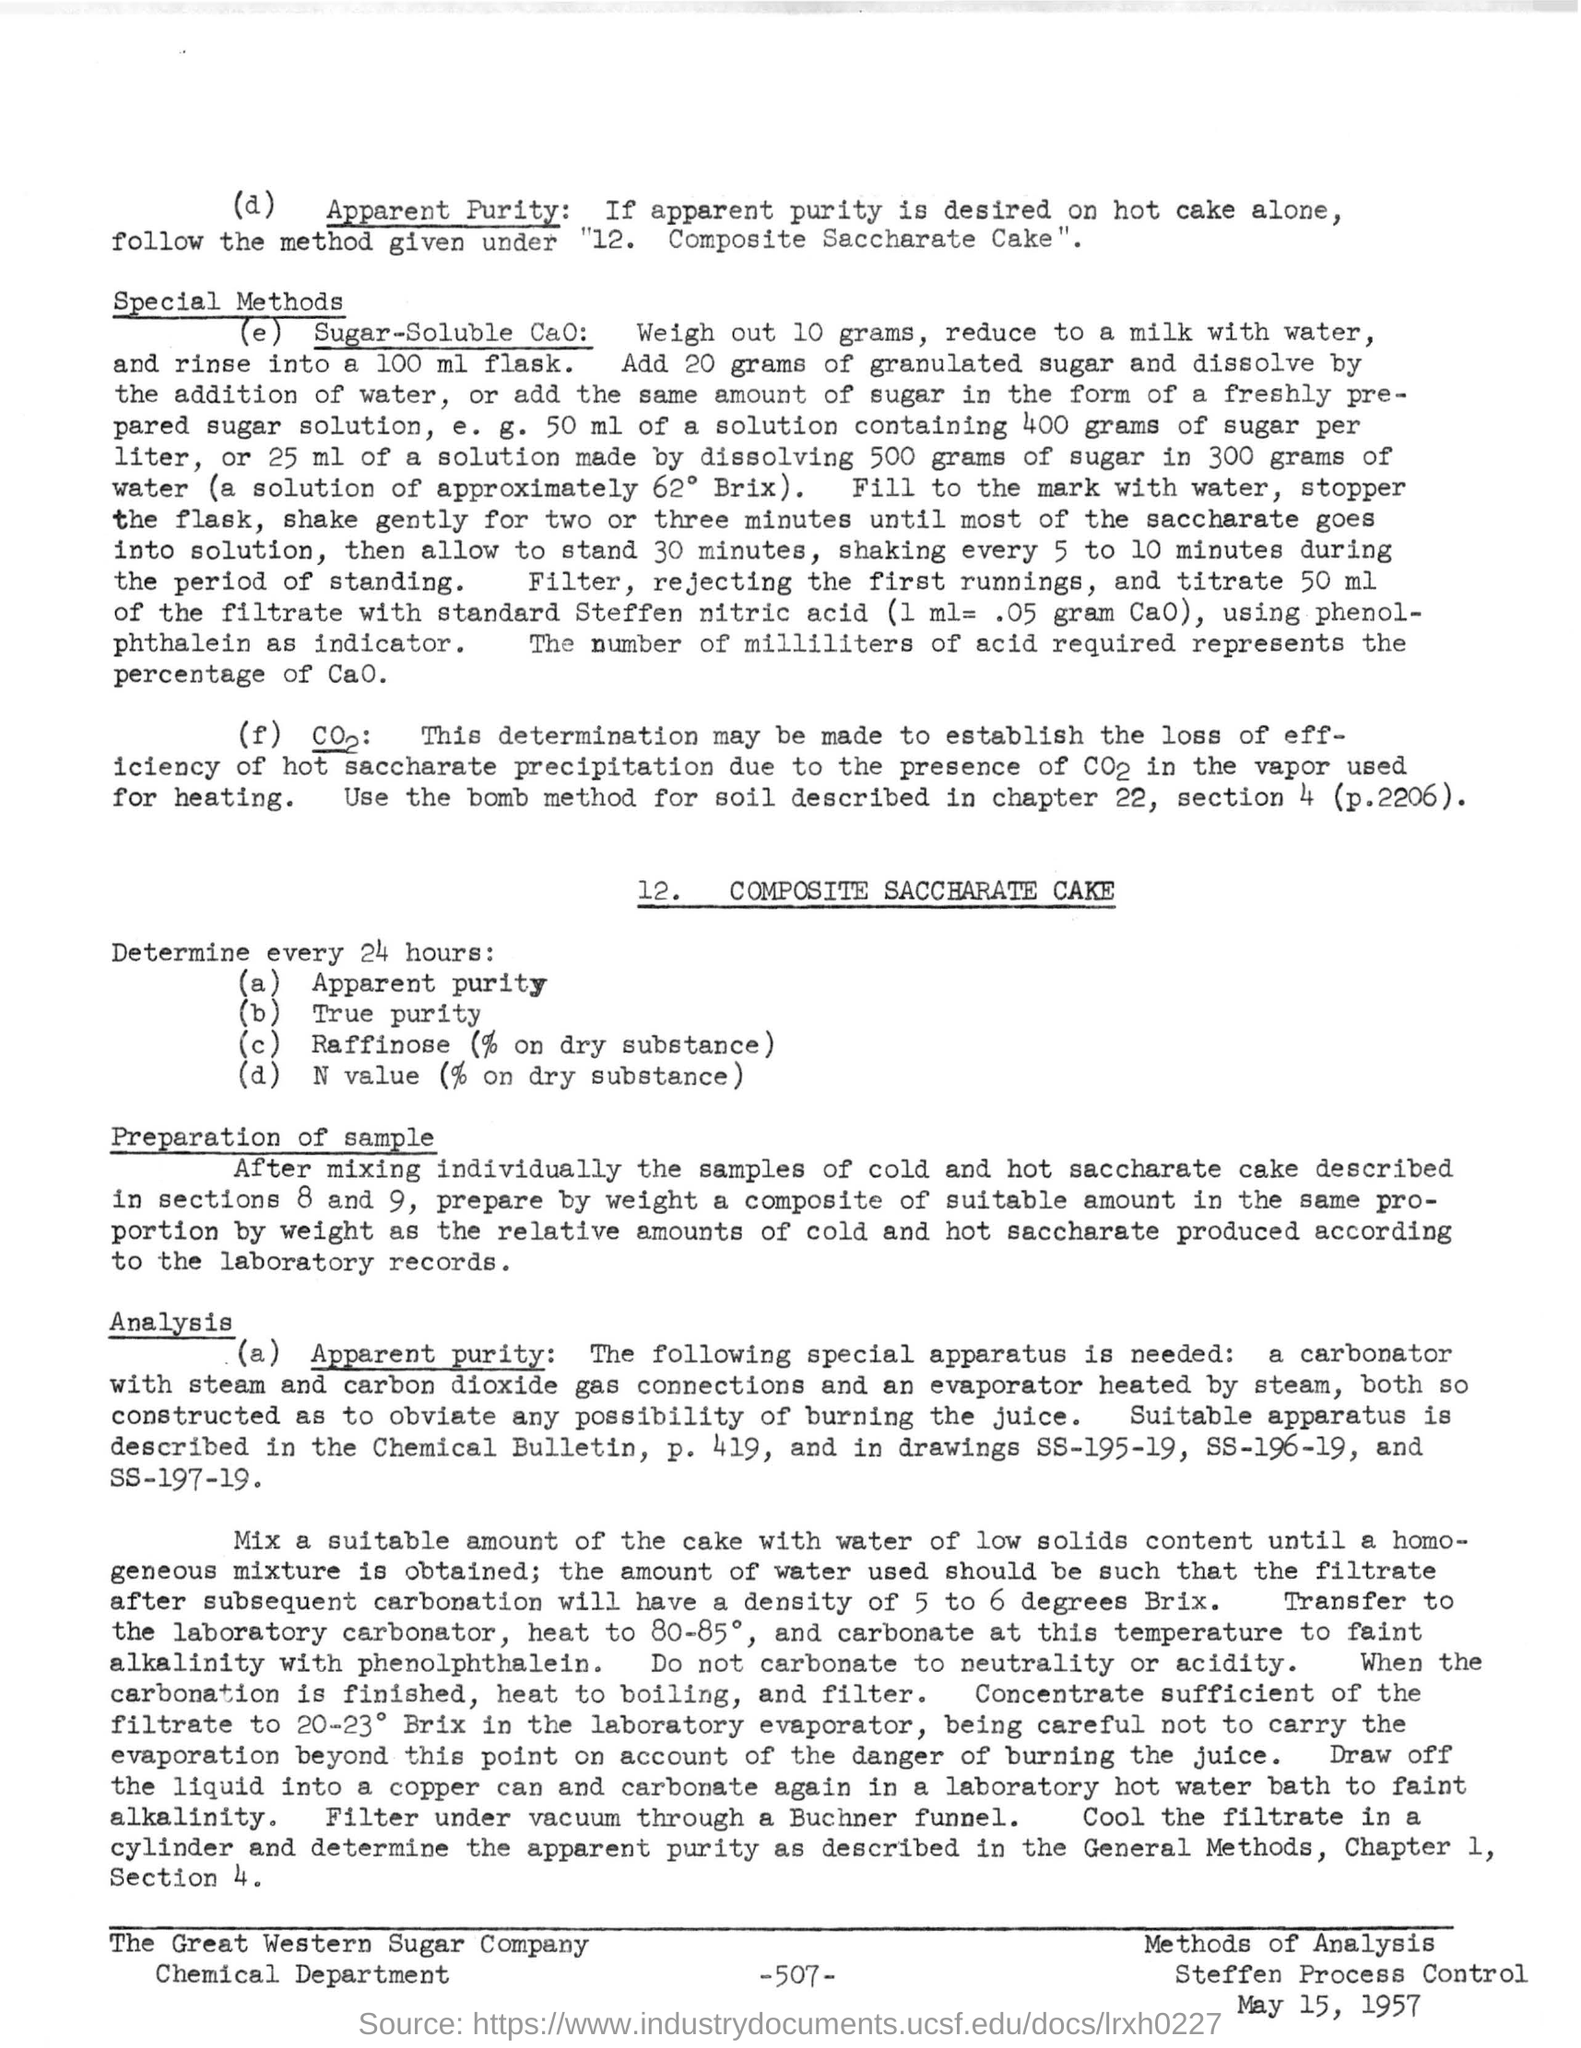What is the date mentioned in the bottom of the document ?
Your response must be concise. May 15, 1957. What is the number written in the bottom of the document ?
Make the answer very short. 507. 